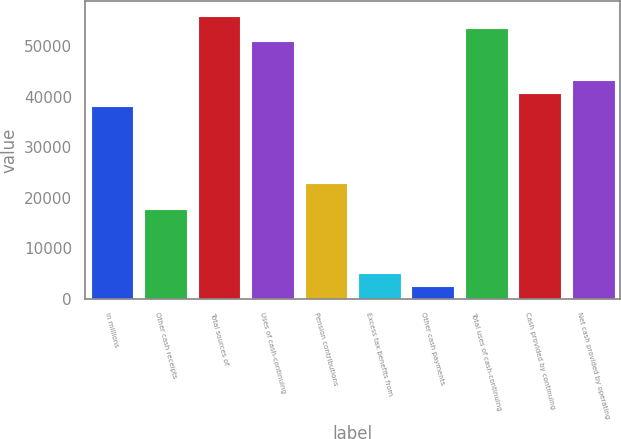<chart> <loc_0><loc_0><loc_500><loc_500><bar_chart><fcel>in millions<fcel>Other cash receipts<fcel>Total sources of<fcel>Uses of cash-continuing<fcel>Pension contributions<fcel>Excess tax benefits from<fcel>Other cash payments<fcel>Total uses of cash-continuing<fcel>Cash provided by continuing<fcel>Net cash provided by operating<nl><fcel>38193<fcel>17825<fcel>56015<fcel>50923<fcel>22917<fcel>5095<fcel>2549<fcel>53469<fcel>40739<fcel>43285<nl></chart> 